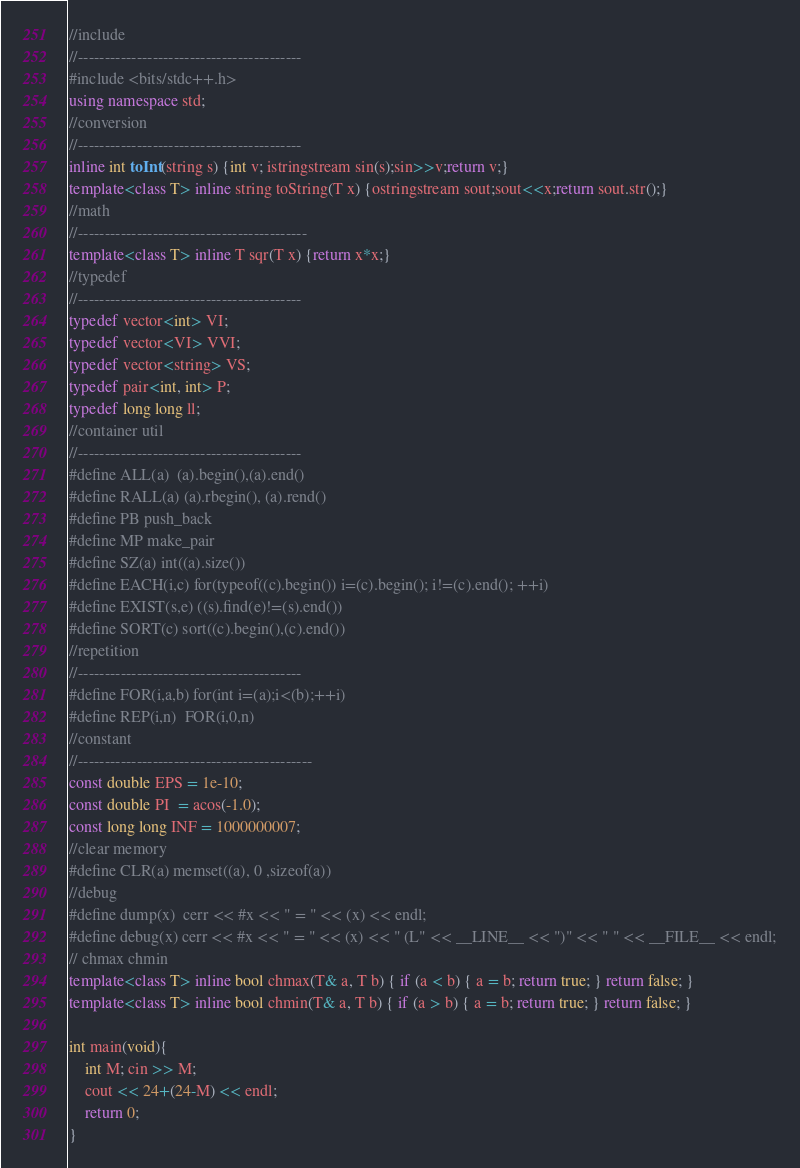Convert code to text. <code><loc_0><loc_0><loc_500><loc_500><_C++_>//include
//------------------------------------------
#include <bits/stdc++.h>
using namespace std;
//conversion
//------------------------------------------
inline int toInt(string s) {int v; istringstream sin(s);sin>>v;return v;}
template<class T> inline string toString(T x) {ostringstream sout;sout<<x;return sout.str();}
//math
//-------------------------------------------
template<class T> inline T sqr(T x) {return x*x;}
//typedef
//------------------------------------------
typedef vector<int> VI;
typedef vector<VI> VVI;
typedef vector<string> VS;
typedef pair<int, int> P;
typedef long long ll;
//container util
//------------------------------------------
#define ALL(a)  (a).begin(),(a).end()
#define RALL(a) (a).rbegin(), (a).rend()
#define PB push_back
#define MP make_pair
#define SZ(a) int((a).size())
#define EACH(i,c) for(typeof((c).begin()) i=(c).begin(); i!=(c).end(); ++i)
#define EXIST(s,e) ((s).find(e)!=(s).end())
#define SORT(c) sort((c).begin(),(c).end())
//repetition
//------------------------------------------
#define FOR(i,a,b) for(int i=(a);i<(b);++i)
#define REP(i,n)  FOR(i,0,n)
//constant
//--------------------------------------------
const double EPS = 1e-10;
const double PI  = acos(-1.0);
const long long INF = 1000000007;
//clear memory
#define CLR(a) memset((a), 0 ,sizeof(a))
//debug
#define dump(x)  cerr << #x << " = " << (x) << endl;
#define debug(x) cerr << #x << " = " << (x) << " (L" << __LINE__ << ")" << " " << __FILE__ << endl;
// chmax chmin
template<class T> inline bool chmax(T& a, T b) { if (a < b) { a = b; return true; } return false; }
template<class T> inline bool chmin(T& a, T b) { if (a > b) { a = b; return true; } return false; }

int main(void){
    int M; cin >> M;
    cout << 24+(24-M) << endl;
    return 0;
}</code> 